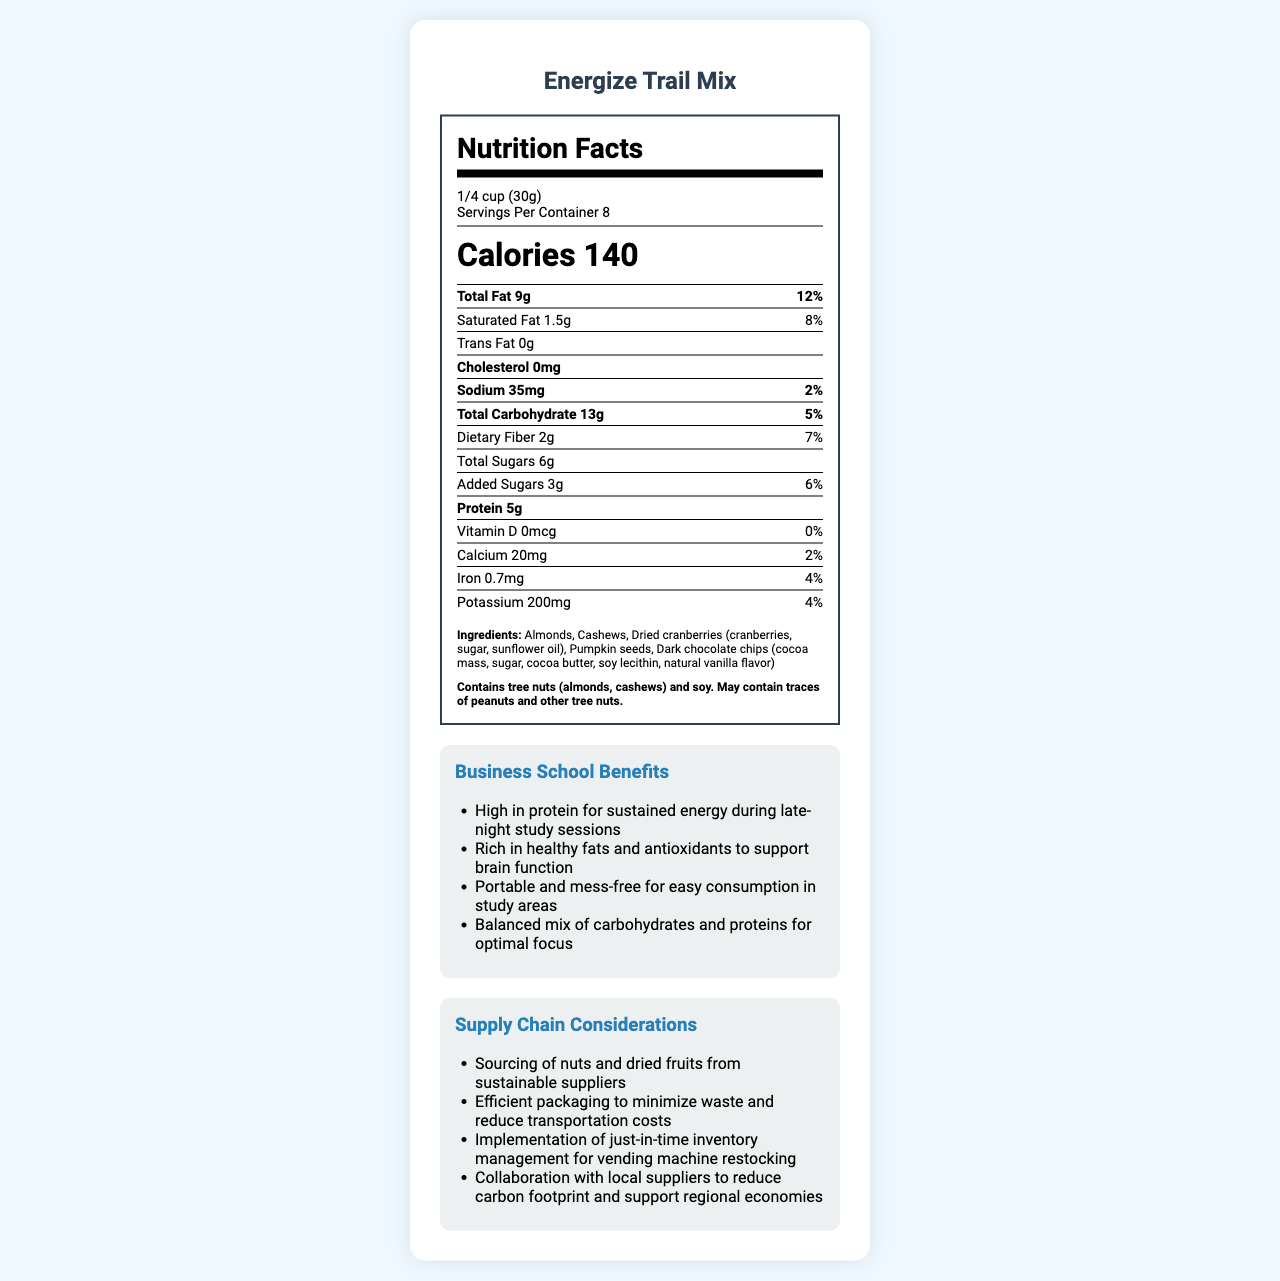what is the serving size of Energize Trail Mix? The serving size is clearly listed in the document as "1/4 cup (30g)."
Answer: 1/4 cup (30g) how many servings are in one container of Energize Trail Mix? The document states that there are 8 servings per container.
Answer: 8 what is the total fat content in one serving? The total fat content per serving is listed as 9g.
Answer: 9g how much protein does one serving contain? The protein content per serving is specified as 5g.
Answer: 5g what is the percent daily value of dietary fiber per serving? The daily value of dietary fiber per serving is listed as 7%.
Answer: 7% what are the ingredients in Energize Trail Mix? The ingredients are clearly listed in the document.
Answer: Almonds, Cashews, Dried cranberries (cranberries, sugar, sunflower oil), Pumpkin seeds, Dark chocolate chips (cocoa mass, sugar, cocoa butter, soy lecithin, natural vanilla flavor) how much sodium is in a single serving? The sodium content per serving is 35mg.
Answer: 35mg which of the following vitamins or minerals has the highest daily value percentage in Energize Trail Mix? A. Calcium B. Iron C. Potassium Potassium has a daily value percentage of 4%, which is the highest among the listed options.
Answer: C. Potassium what is the total amount of sugars per serving? A. 3g B. 4g C. 5g D. 6g The total amount of sugars per serving is 6g.
Answer: D. 6g is there any cholesterol in Energize Trail Mix? The document states that there is 0mg of cholesterol in the trail mix.
Answer: No how does Energize Trail Mix benefit business school students? The document lists several benefits specifically for business school students.
Answer: High in protein for sustained energy during late-night study sessions, Rich in healthy fats and antioxidants to support brain function, Portable and mess-free for easy consumption in study areas, Balanced mix of carbohydrates and proteins for optimal focus what is the main idea of the document? The document provides detailed nutritional facts, ingredients, business school benefits, and supply chain considerations related to Energize Trail Mix.
Answer: To provide nutritional and supply chain information about Energize Trail Mix, a healthy snack option promoted in business school vending machines. who manufactures Energize Trail Mix? The manufacturer of the product is listed as HealthySnacks Co.
Answer: HealthySnacks Co. how does the supply chain of Energize Trail Mix ensure sustainability? One of the supply chain considerations mentioned is sourcing nuts and dried fruits from sustainable suppliers.
Answer: Sourcing of nuts and dried fruits from sustainable suppliers what is the purpose of including supply chain considerations in the document? The document includes supply chain considerations to show efforts in efficiency, sustainability, and regional support.
Answer: To highlight the efforts in minimizing waste, reducing transportation costs, and supporting regional economies how are the nuts and dried fruits in Energize Trail Mix sourced? The document states that nuts and dried fruits are sourced from sustainable suppliers but doesn't specify the exact sourcing process.
Answer: Cannot be determined 